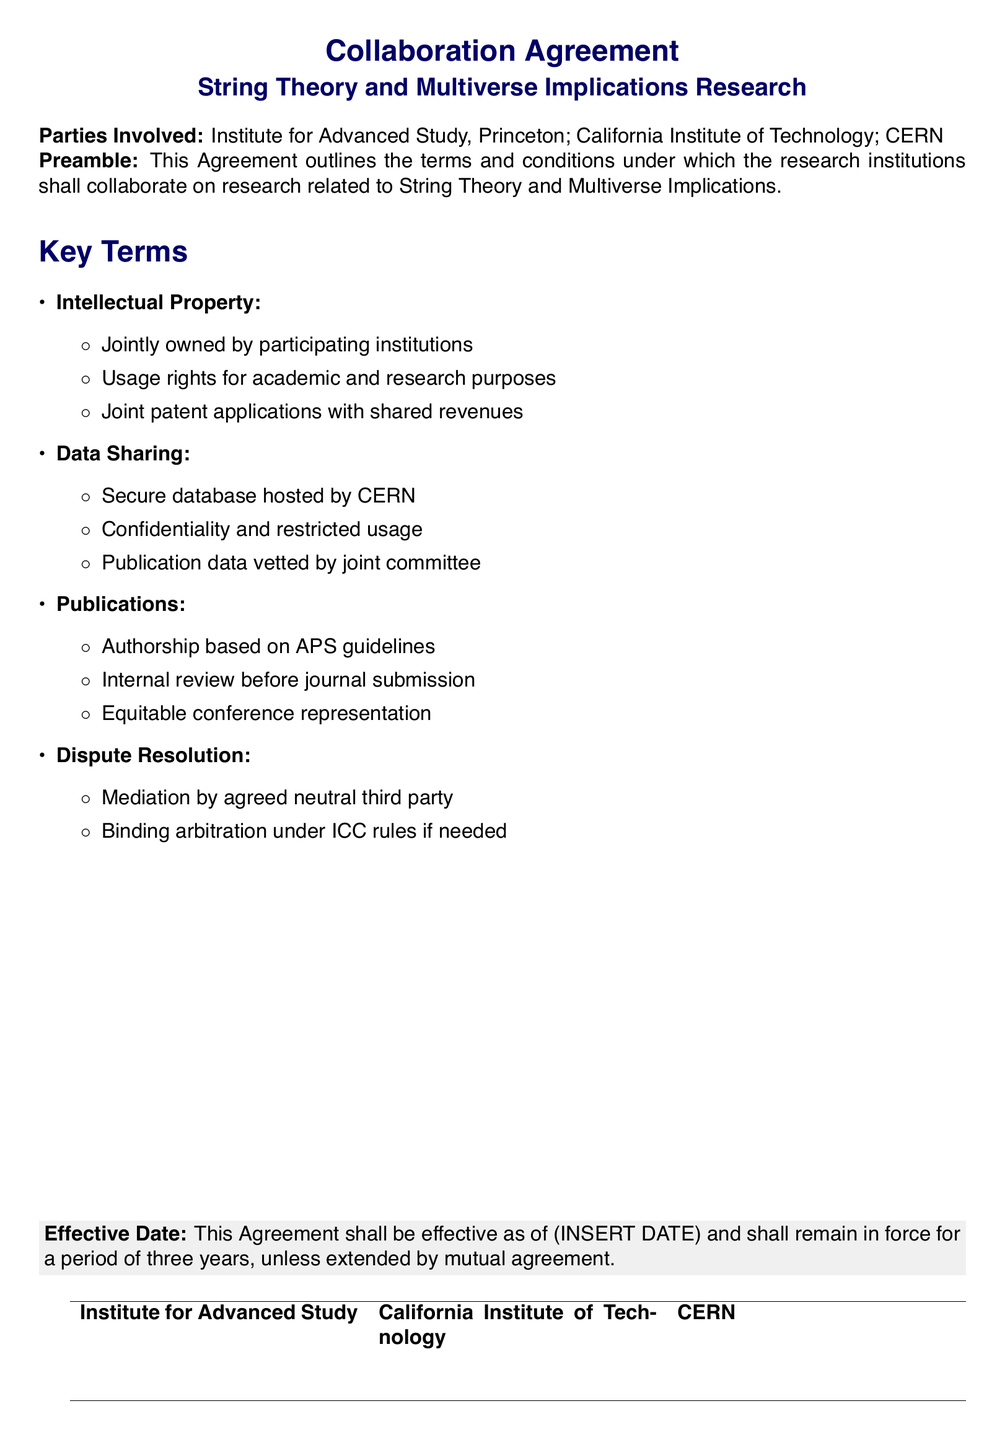What are the parties involved? The document lists three research institutions involved in the collaboration.
Answer: Institute for Advanced Study, Princeton; California Institute of Technology; CERN What is the effective duration of the agreement? The document states the agreement is in force for a specific period.
Answer: Three years Who owns the intellectual property? The document specifies the ownership details regarding intellectual property rights.
Answer: Jointly owned What does the data sharing protocol include? The document outlines specific details about how data will be shared among institutions.
Answer: Secure database hosted by CERN What guidelines are used for authorship? The document mentions specific guidelines that will determine authorship in publications.
Answer: APS guidelines What is the procedure for internal review? The document describes how publication submissions will be handled before reaching journals.
Answer: Internal review before journal submission What is required for dispute resolution? The document outlines the process in case of disagreements between parties.
Answer: Mediation by agreed neutral third party What kind of committee is mentioned for vetting publication data? The document specifies the type of committee responsible for publication data oversight.
Answer: Joint committee What will happen if binding arbitration is needed? The document describes a resolution method if mediation fails.
Answer: Under ICC rules 